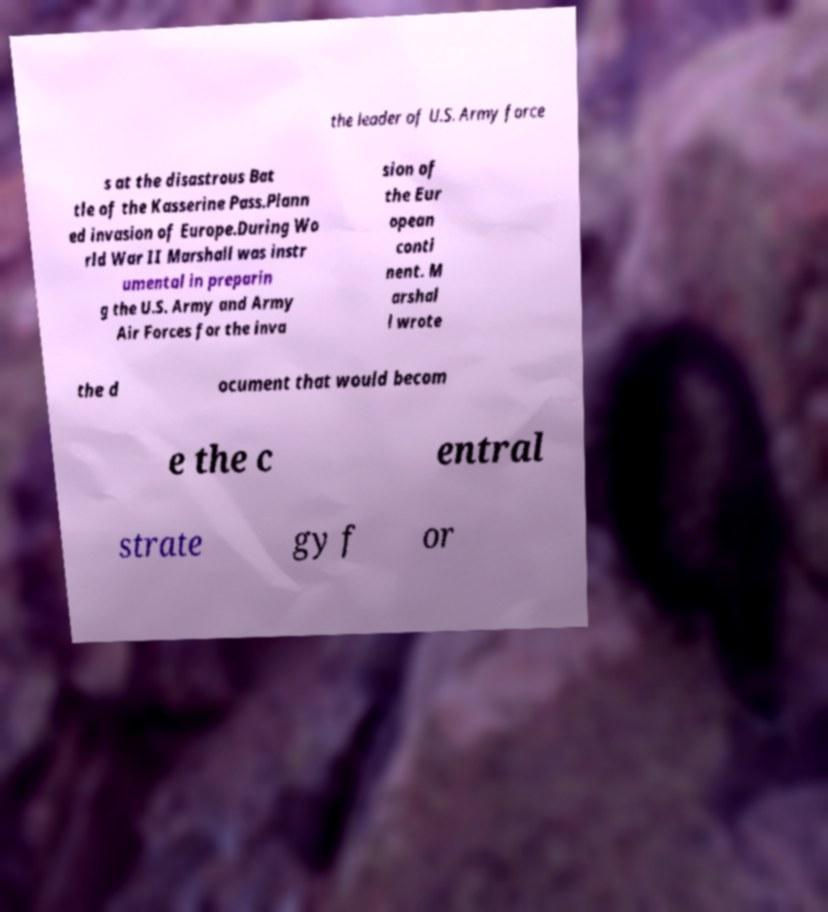Please identify and transcribe the text found in this image. the leader of U.S. Army force s at the disastrous Bat tle of the Kasserine Pass.Plann ed invasion of Europe.During Wo rld War II Marshall was instr umental in preparin g the U.S. Army and Army Air Forces for the inva sion of the Eur opean conti nent. M arshal l wrote the d ocument that would becom e the c entral strate gy f or 